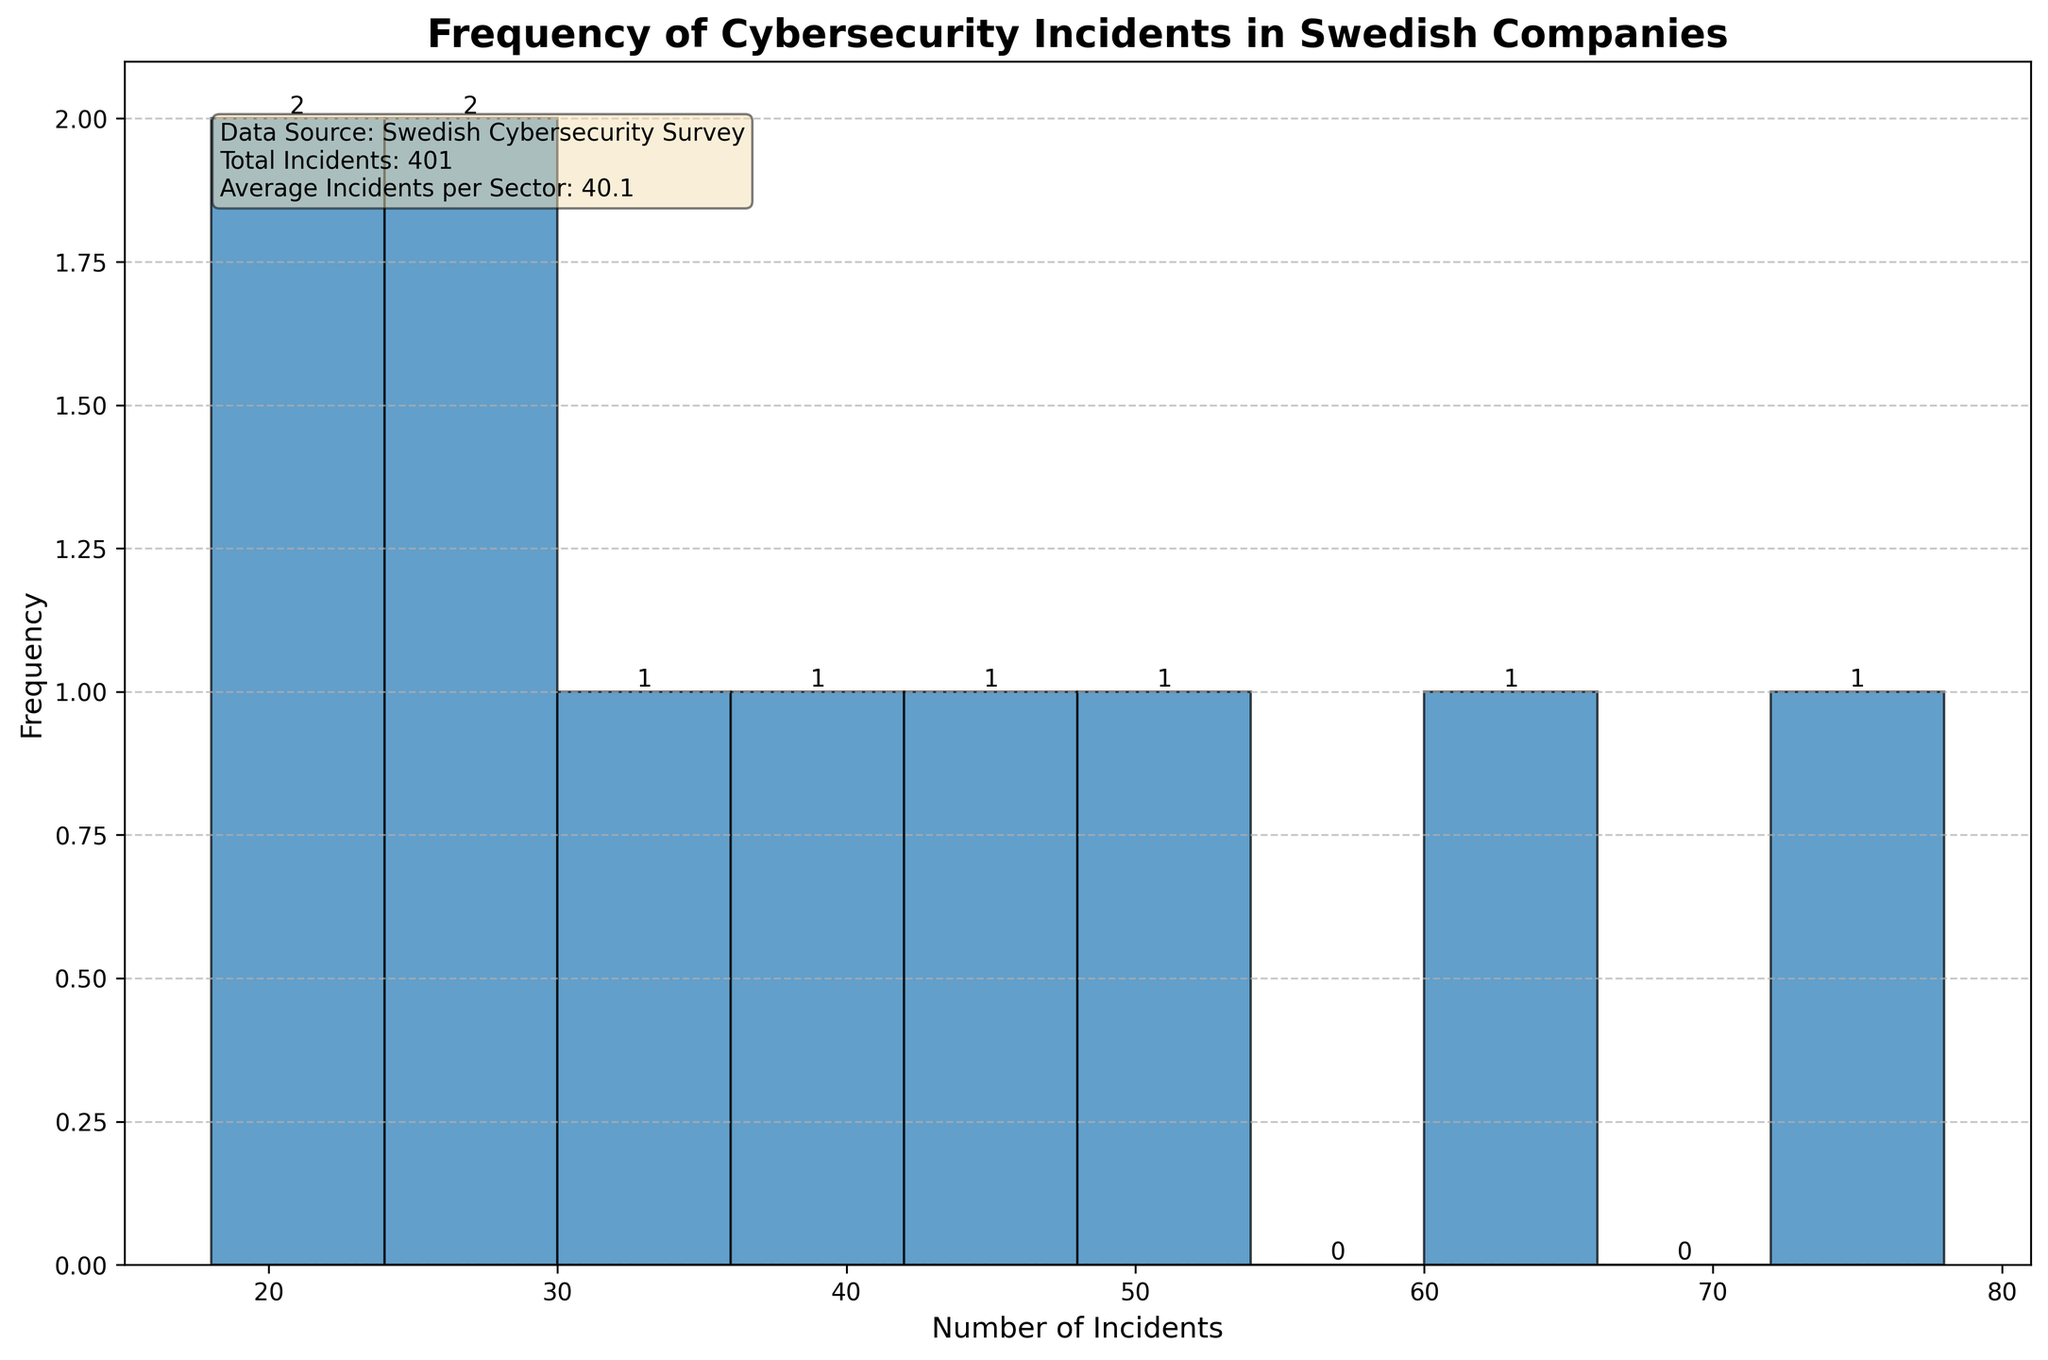What's the title of the figure? The title of the figure is displayed prominently at the top of the plot, usually in a larger font size and bold. It provides a brief description of what the chart represents.
Answer: Frequency of Cybersecurity Incidents in Swedish Companies What does the x-axis represent? The x-axis label is usually found along the horizontal axis of the chart and provides context for the data points plotted along this axis. In this case, the label is indicated clearly below the axis.
Answer: Number of Incidents How many industry sectors are represented in the histogram? Each bar in the histogram represents the frequency of cybersecurity incidents within discrete intervals. By counting the number of bars, we can determine how many industry sectors are represented.
Answer: 10 Which industry sector has the highest number of cybersecurity incidents? By looking at the bar with the highest value along the x-axis, we can identify the corresponding industry sector with the most incidents. According to the dataset, this is the bar labeled "Finance."
Answer: Finance What is the average number of incidents per sector? According to the text box in the plot, the average number of incidents is calculated and displayed. This value represents the mean of the dataset and is calculated by summing up all incidents and dividing by the number of sectors. Discussing the math is not necessary here since the value is given.
Answer: 40.1 How many sectors have fewer than 30 cybersecurity incidents? By observing the bars and their corresponding frequencies below the 30 incidents mark on the x-axis, we can count the relevant bars. The exact count can be determined visually.
Answer: 4 What is the frequency of sectors with incidents between 40 and 50? We need to find the bars within the interval 40 to 50 on the x-axis and observe their frequency by looking at the height of the bars within this range.
Answer: 1 How many sectors have more than 50 cybersecurity incidents? We review the bars to the right of the 50 incidents mark on the x-axis and count these bars to determine how many sectors exceed 50 incidents.
Answer: 3 Which sector has the smallest number of incidents, and what is that number? By locating the bar representing the least number of incidents, we determine both the sector and the incident count. According to the dataset, this value corresponds to "Transportation."
Answer: Transportation, 18 What is the total number of cybersecurity incidents across all sectors? The text box in the plot provides the total number of incidents. This summarization in the box eliminates the need for manual addition.
Answer: 401 